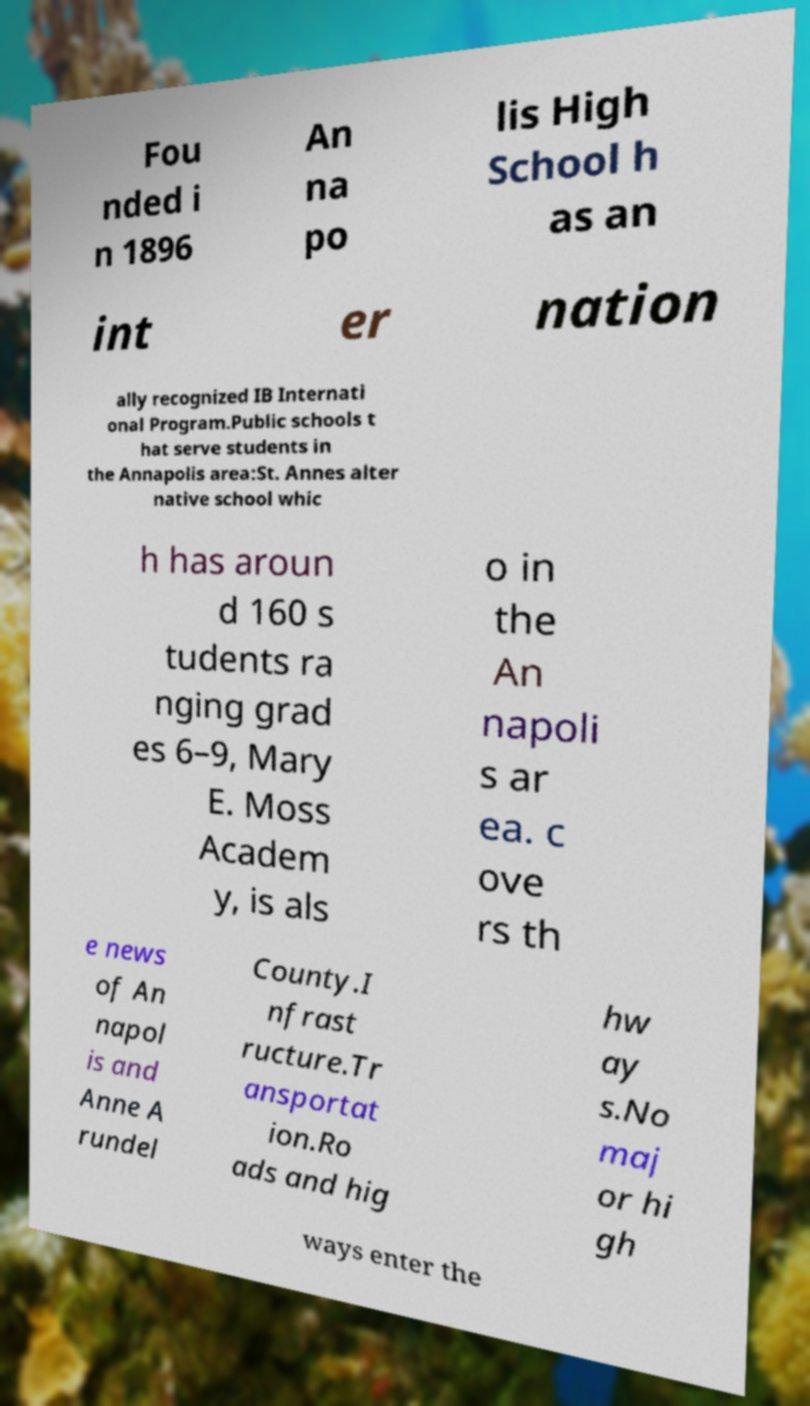Could you assist in decoding the text presented in this image and type it out clearly? Fou nded i n 1896 An na po lis High School h as an int er nation ally recognized IB Internati onal Program.Public schools t hat serve students in the Annapolis area:St. Annes alter native school whic h has aroun d 160 s tudents ra nging grad es 6–9, Mary E. Moss Academ y, is als o in the An napoli s ar ea. c ove rs th e news of An napol is and Anne A rundel County.I nfrast ructure.Tr ansportat ion.Ro ads and hig hw ay s.No maj or hi gh ways enter the 